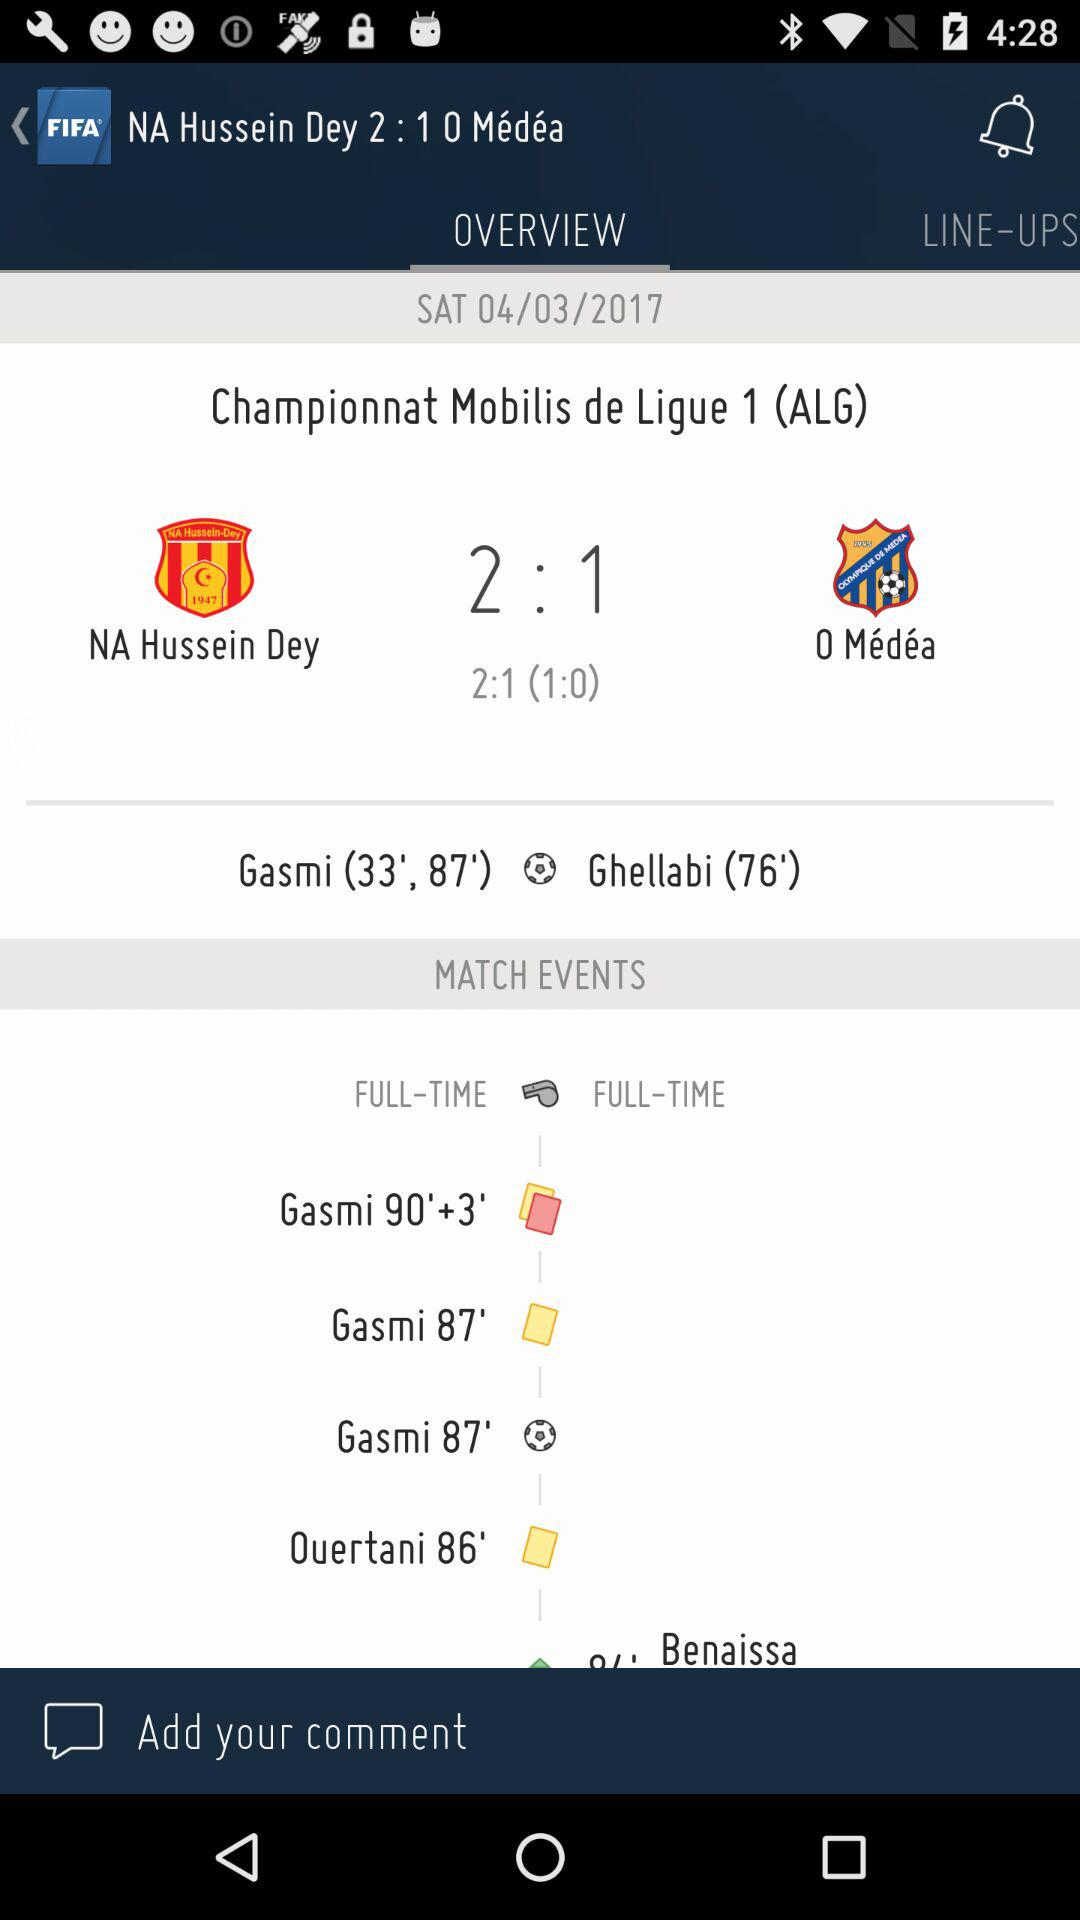How many minutes after Gasmi's first goal did he score his second goal?
Answer the question using a single word or phrase. 54 